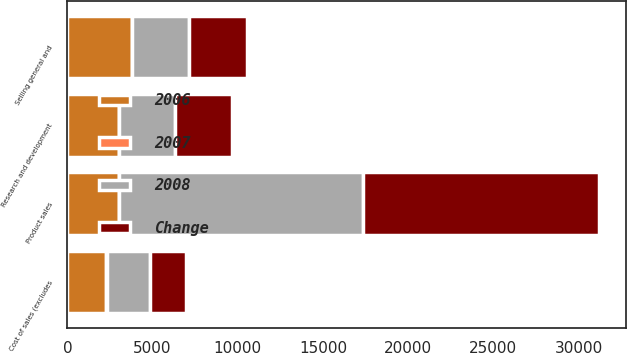Convert chart. <chart><loc_0><loc_0><loc_500><loc_500><stacked_bar_chart><ecel><fcel>Product sales<fcel>Cost of sales (excludes<fcel>Research and development<fcel>Selling general and<nl><fcel>2006<fcel>3030<fcel>2296<fcel>3030<fcel>3789<nl><fcel>2007<fcel>3<fcel>10<fcel>7<fcel>13<nl><fcel>2008<fcel>14311<fcel>2548<fcel>3266<fcel>3361<nl><fcel>Change<fcel>13858<fcel>2095<fcel>3366<fcel>3366<nl></chart> 